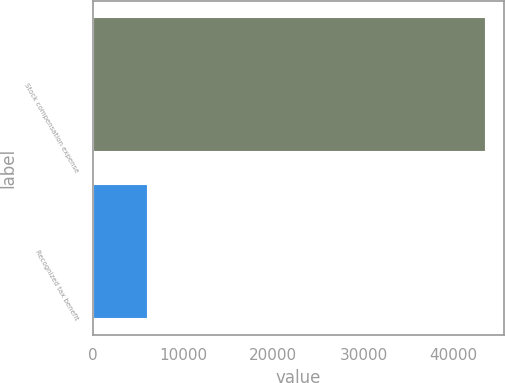Convert chart. <chart><loc_0><loc_0><loc_500><loc_500><bar_chart><fcel>Stock compensation expense<fcel>Recognized tax benefit<nl><fcel>43415<fcel>6010<nl></chart> 